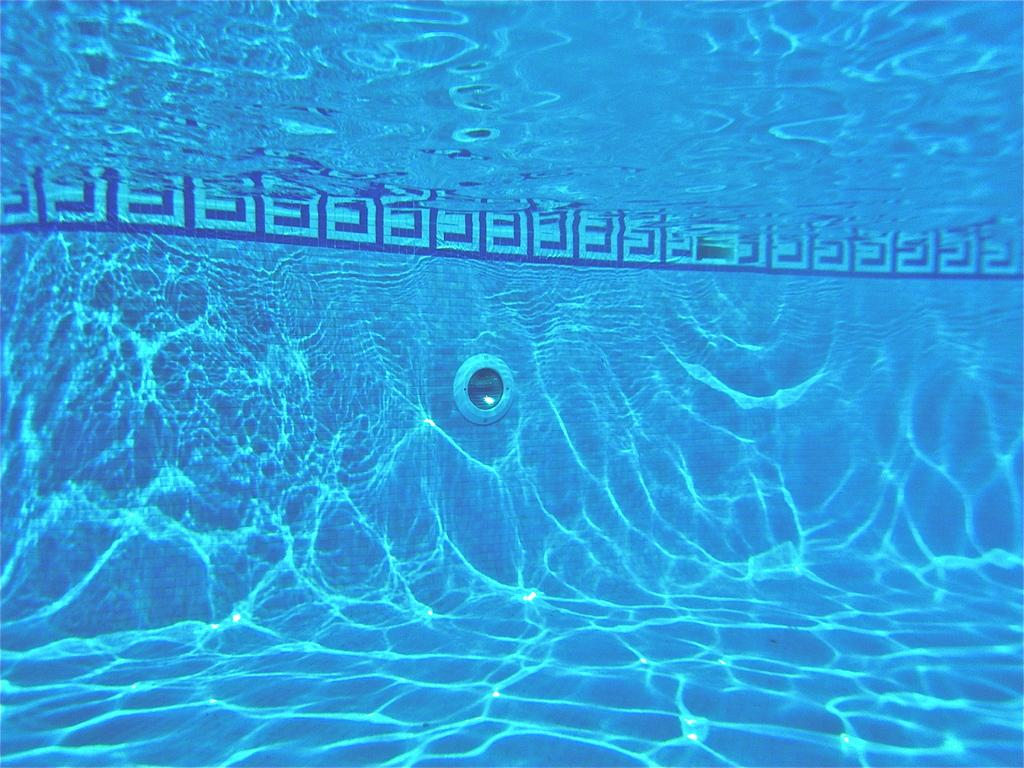What is the primary setting of the image? The image is inside the water of a swimming pool. Can you describe the environment in which the image is taken? The image is taken in a swimming pool, which is a body of water typically used for recreational activities. What type of dirt can be seen on the surface of the earth in the image? There is no dirt or earth visible in the image, as it is taken inside the water of a swimming pool. 